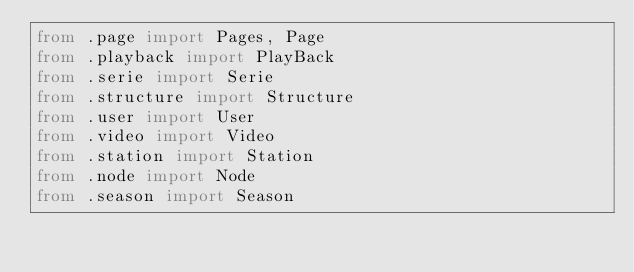<code> <loc_0><loc_0><loc_500><loc_500><_Python_>from .page import Pages, Page
from .playback import PlayBack
from .serie import Serie
from .structure import Structure
from .user import User
from .video import Video
from .station import Station
from .node import Node
from .season import Season
</code> 